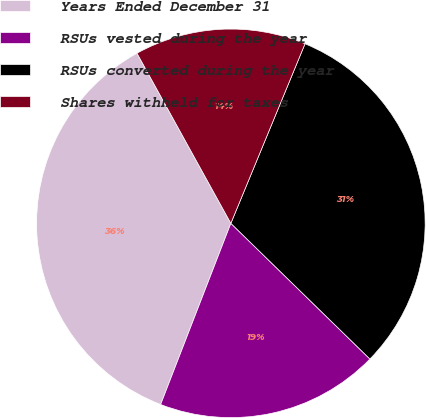<chart> <loc_0><loc_0><loc_500><loc_500><pie_chart><fcel>Years Ended December 31<fcel>RSUs vested during the year<fcel>RSUs converted during the year<fcel>Shares withheld for taxes<nl><fcel>36.09%<fcel>18.58%<fcel>31.07%<fcel>14.26%<nl></chart> 